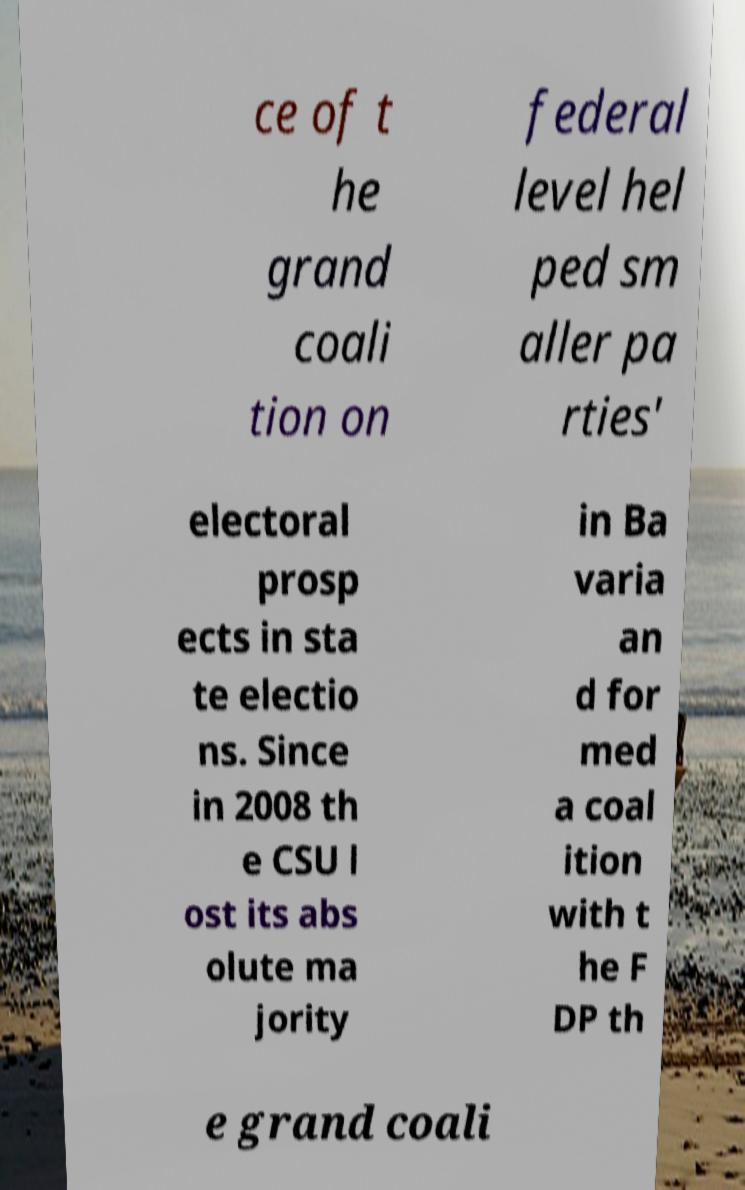Can you read and provide the text displayed in the image?This photo seems to have some interesting text. Can you extract and type it out for me? ce of t he grand coali tion on federal level hel ped sm aller pa rties' electoral prosp ects in sta te electio ns. Since in 2008 th e CSU l ost its abs olute ma jority in Ba varia an d for med a coal ition with t he F DP th e grand coali 